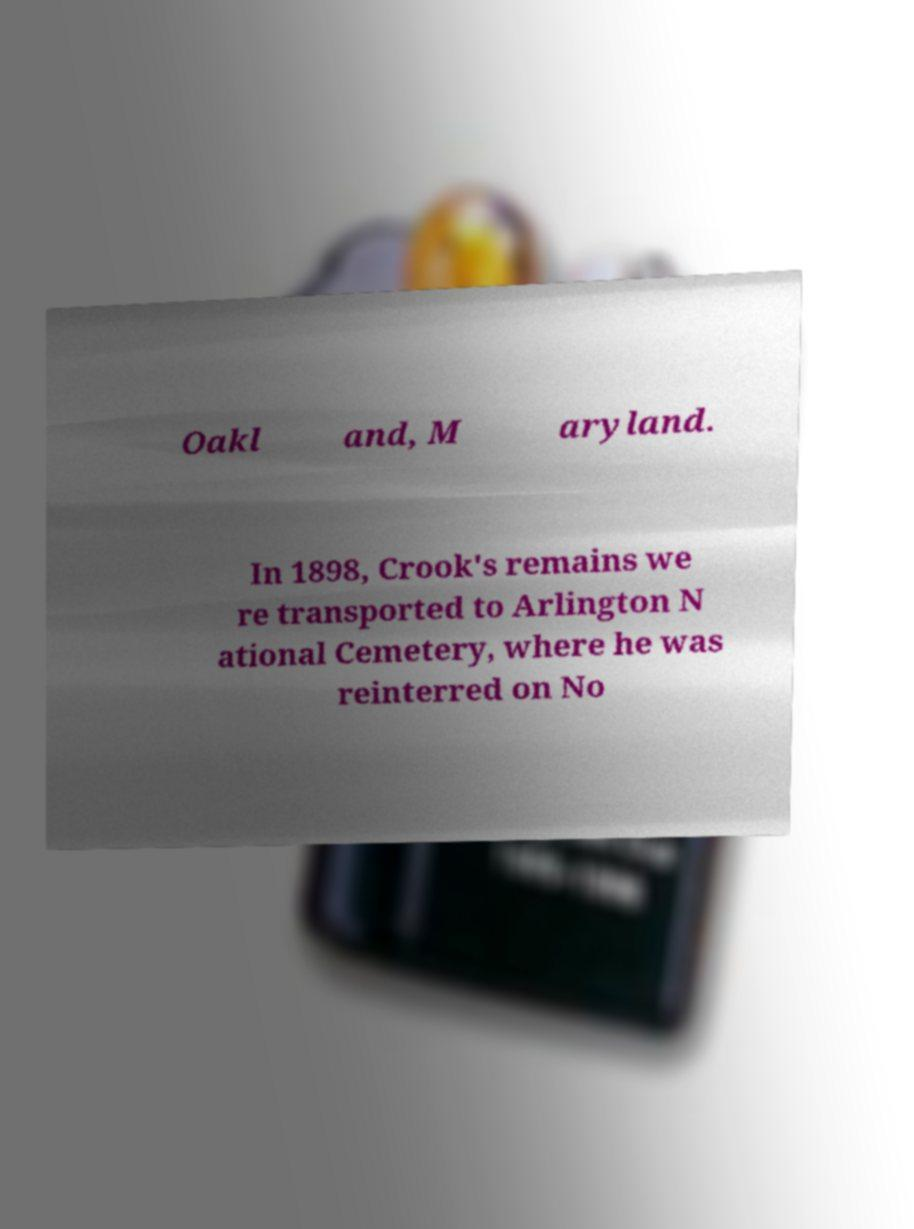What messages or text are displayed in this image? I need them in a readable, typed format. Oakl and, M aryland. In 1898, Crook's remains we re transported to Arlington N ational Cemetery, where he was reinterred on No 